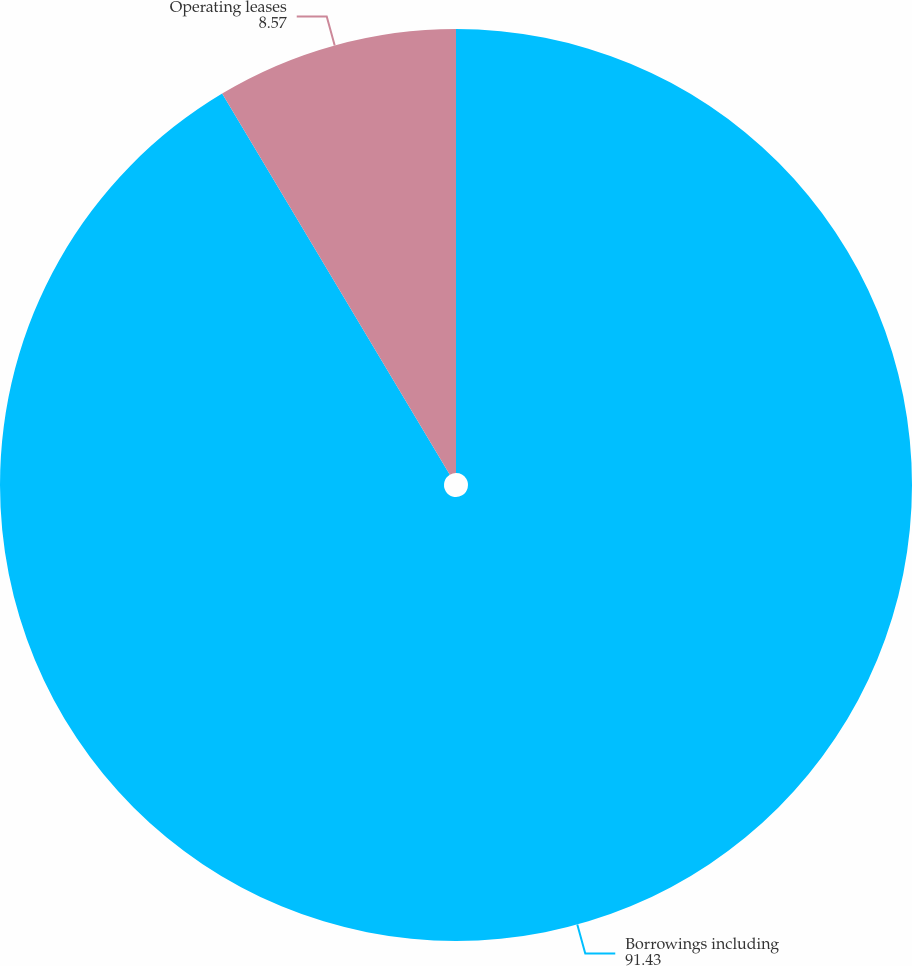Convert chart to OTSL. <chart><loc_0><loc_0><loc_500><loc_500><pie_chart><fcel>Borrowings including<fcel>Operating leases<nl><fcel>91.43%<fcel>8.57%<nl></chart> 